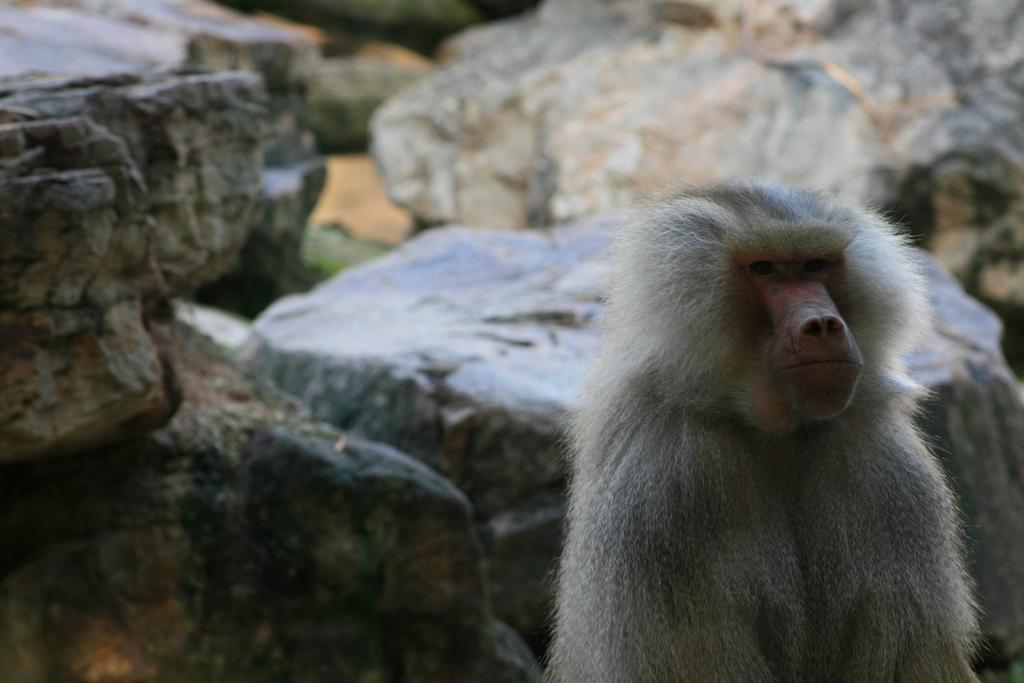What animal is located on the right side of the image? There is a monkey on the right side of the image. What can be seen in the background of the image? There are stones visible in the background of the image. What type of sign is the monkey holding in the image? There is no sign present in the image; the monkey is not holding anything. 